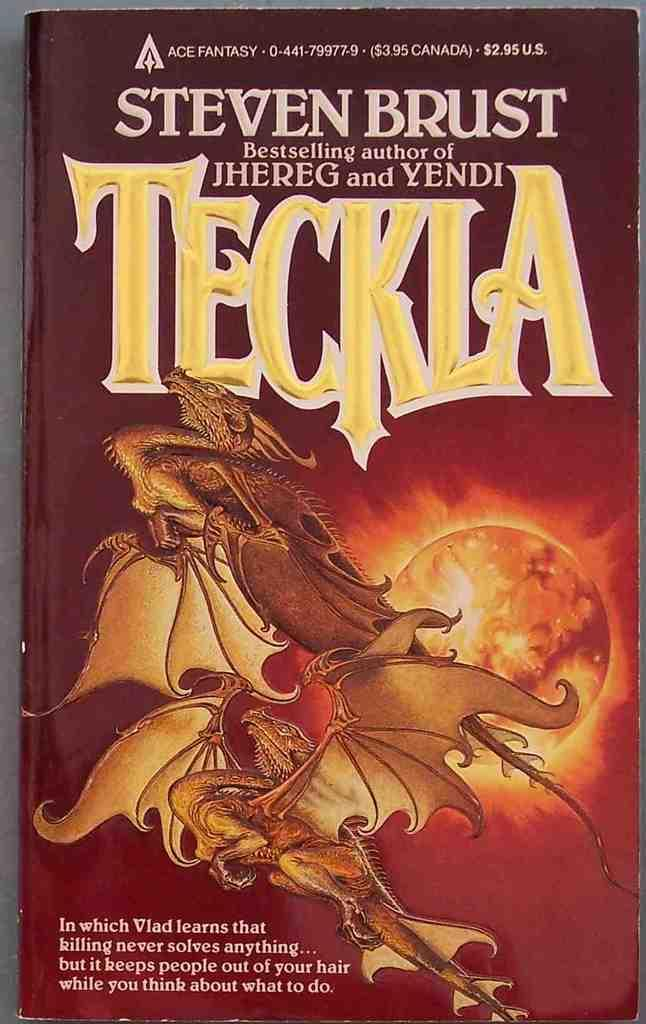Provide a one-sentence caption for the provided image. A book that is about fantasy titled Teckla. 